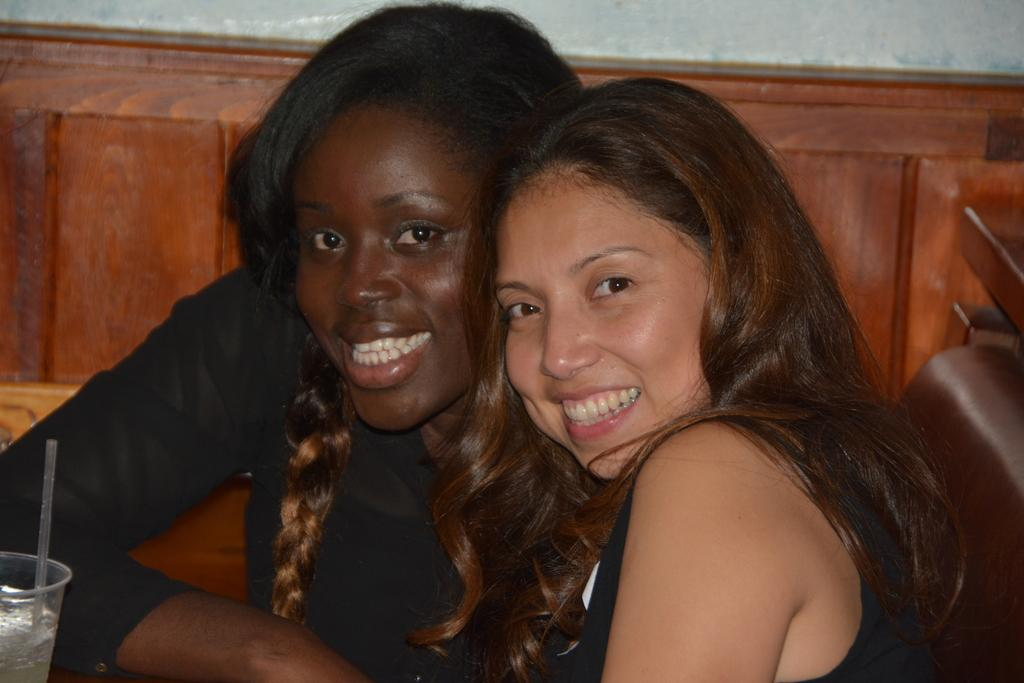How many women are in the image? There are two women in the image. What is the appearance of one of the women? One of the women is wearing a black dress. What can be seen on the left side of the image? There is a glass with a straw in it on the left side of the image. What type of clouds can be seen in the image? There are no clouds visible in the image. How many spoons are present in the image? There is no spoon mentioned or visible in the image. 